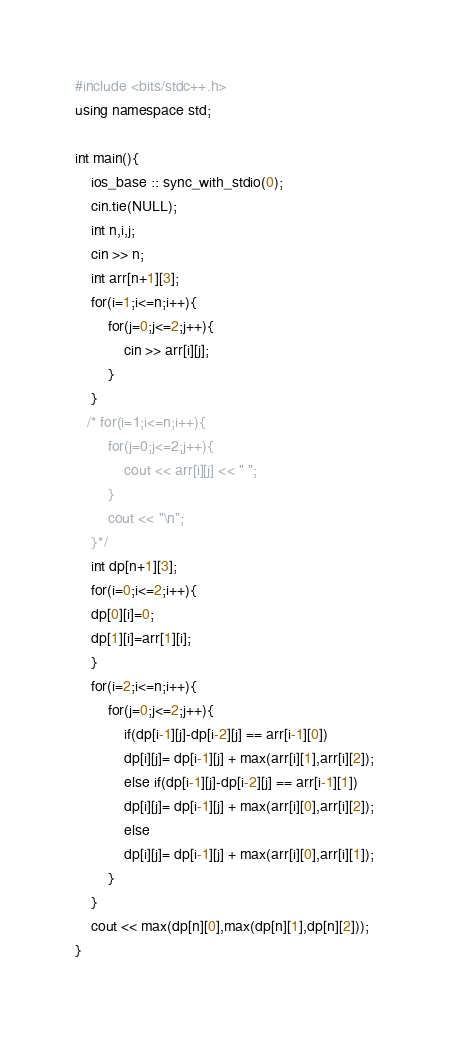<code> <loc_0><loc_0><loc_500><loc_500><_C++_>#include <bits/stdc++.h>
using namespace std;

int main(){
    ios_base :: sync_with_stdio(0);
    cin.tie(NULL);
    int n,i,j;
    cin >> n;
    int arr[n+1][3];
    for(i=1;i<=n;i++){
        for(j=0;j<=2;j++){
            cin >> arr[i][j];
        }
    }
   /* for(i=1;i<=n;i++){
        for(j=0;j<=2;j++){
            cout << arr[i][j] << " ";
        }
        cout << "\n";
    }*/
    int dp[n+1][3];
    for(i=0;i<=2;i++){
    dp[0][i]=0;
    dp[1][i]=arr[1][i];
    }
    for(i=2;i<=n;i++){
        for(j=0;j<=2;j++){
            if(dp[i-1][j]-dp[i-2][j] == arr[i-1][0])
            dp[i][j]= dp[i-1][j] + max(arr[i][1],arr[i][2]);
            else if(dp[i-1][j]-dp[i-2][j] == arr[i-1][1])
            dp[i][j]= dp[i-1][j] + max(arr[i][0],arr[i][2]);
            else
            dp[i][j]= dp[i-1][j] + max(arr[i][0],arr[i][1]);
        }
    }
    cout << max(dp[n][0],max(dp[n][1],dp[n][2]));
}</code> 